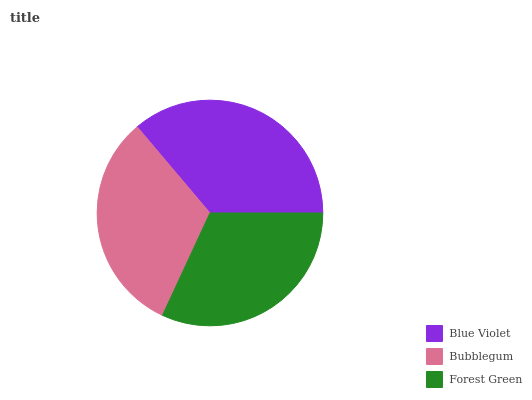Is Forest Green the minimum?
Answer yes or no. Yes. Is Blue Violet the maximum?
Answer yes or no. Yes. Is Bubblegum the minimum?
Answer yes or no. No. Is Bubblegum the maximum?
Answer yes or no. No. Is Blue Violet greater than Bubblegum?
Answer yes or no. Yes. Is Bubblegum less than Blue Violet?
Answer yes or no. Yes. Is Bubblegum greater than Blue Violet?
Answer yes or no. No. Is Blue Violet less than Bubblegum?
Answer yes or no. No. Is Bubblegum the high median?
Answer yes or no. Yes. Is Bubblegum the low median?
Answer yes or no. Yes. Is Blue Violet the high median?
Answer yes or no. No. Is Forest Green the low median?
Answer yes or no. No. 